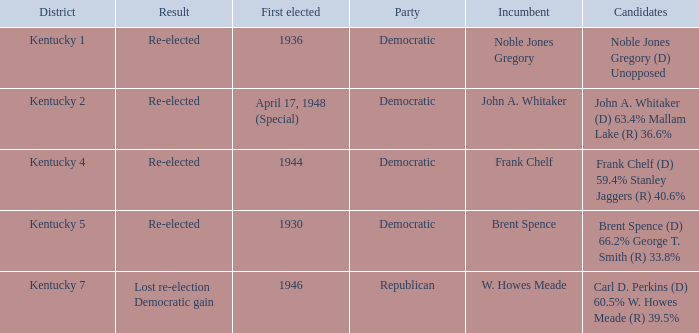Which party won in the election in voting district Kentucky 5? Democratic. 